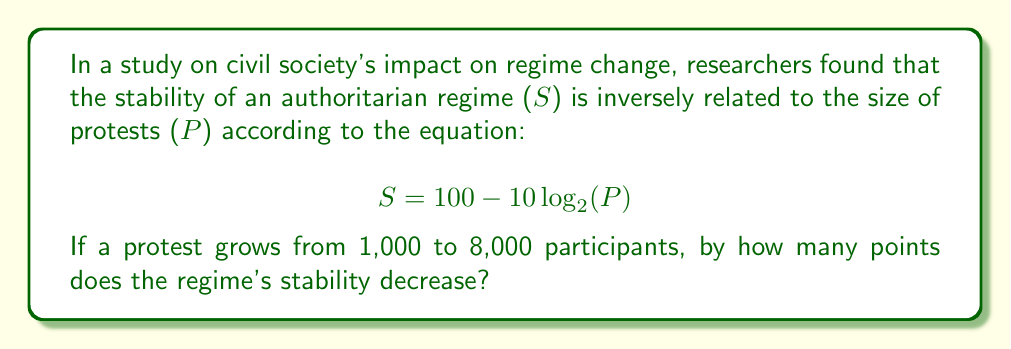Can you answer this question? To solve this problem, we need to calculate the difference in stability between the two protest sizes:

1) For 1,000 participants:
   $S_1 = 100 - 10 \log_{2}(1000)$
   $= 100 - 10 \log_{2}(2^{10})$ (since $2^{10} = 1024 \approx 1000$)
   $= 100 - 10 \cdot 10 = 0$

2) For 8,000 participants:
   $S_2 = 100 - 10 \log_{2}(8000)$
   $= 100 - 10 \log_{2}(2^{13})$ (since $2^{13} = 8192 \approx 8000$)
   $= 100 - 10 \cdot 13 = -30$

3) The decrease in stability is the difference between these two values:
   $\text{Decrease} = S_1 - S_2 = 0 - (-30) = 30$

Therefore, the regime's stability decreases by 30 points when the protest grows from 1,000 to 8,000 participants.
Answer: 30 points 